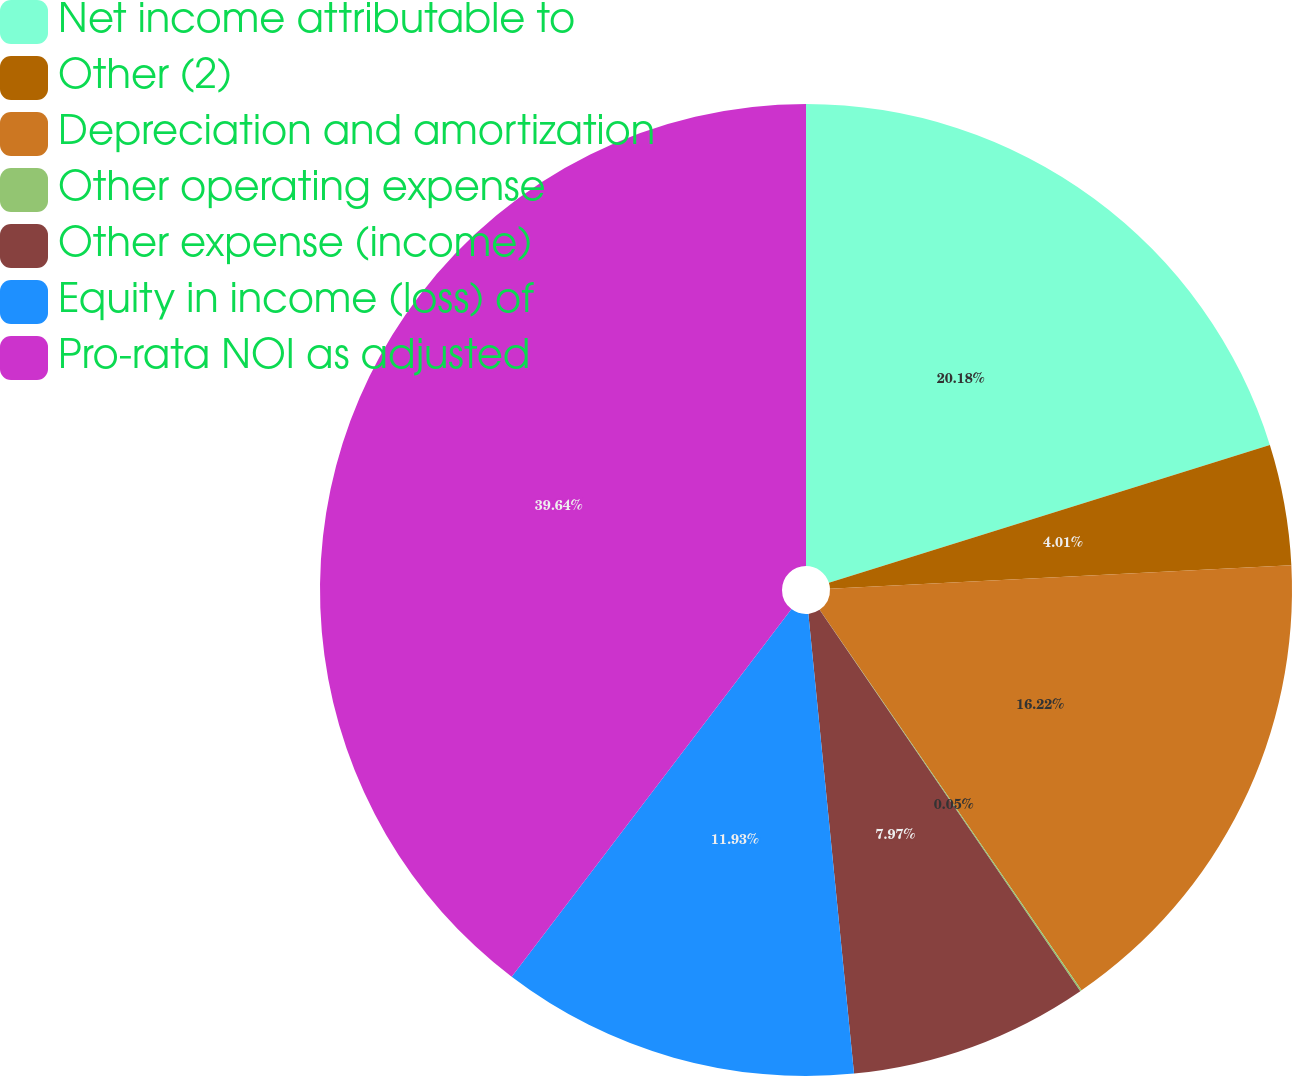Convert chart. <chart><loc_0><loc_0><loc_500><loc_500><pie_chart><fcel>Net income attributable to<fcel>Other (2)<fcel>Depreciation and amortization<fcel>Other operating expense<fcel>Other expense (income)<fcel>Equity in income (loss) of<fcel>Pro-rata NOI as adjusted<nl><fcel>20.18%<fcel>4.01%<fcel>16.22%<fcel>0.05%<fcel>7.97%<fcel>11.93%<fcel>39.65%<nl></chart> 